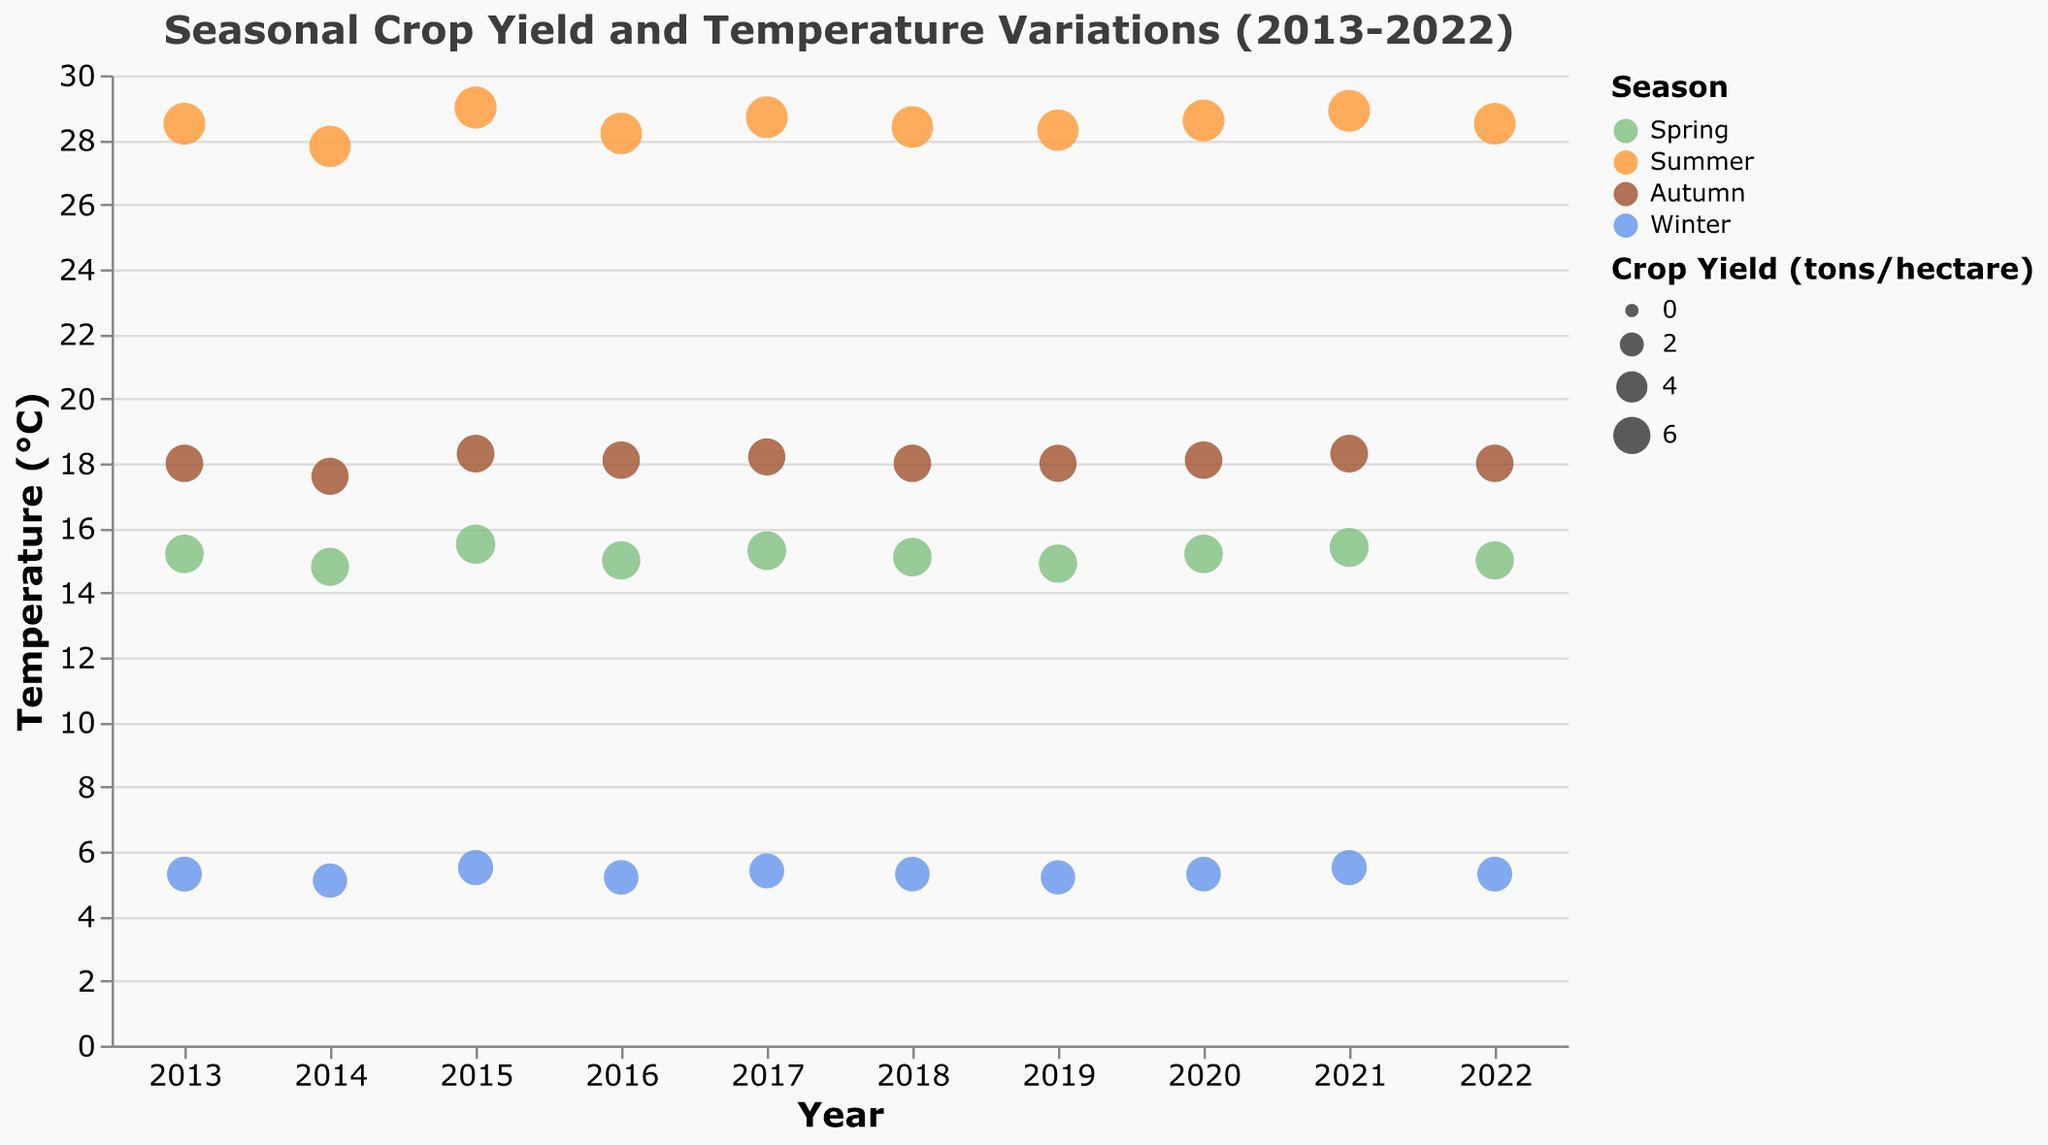1. What is the overall trend in temperatures from 2013 to 2022? Observe the y-axis labeled "Temperature (°C)" and the x-axis labeled "Year". Track the temperatures for each year and season, noting any overall increase or decrease.
Answer: The temperatures seem relatively stable over the years 2. Which season has the highest crop yield consistently across the years? Look at the "Crop Yield (tons/hectare)" represented by the size of the dots. Identify the season with the largest dots consistently from 2013 to 2022.
Answer: Summer 3. How does the crop yield in Spring of 2017 compare to the Spring of 2021? Refer to the "Crop Yield (tons/hectare)" for Spring in the years 2017 and 2021. Compare the sizes of the dots.
Answer: 6.6 (2017) vs 6.7 (2021) 4. What is the highest recorded temperature in the dataset? Check the y-axis labeled "Temperature (°C)" and identify the highest temperature value.
Answer: 29.0°C in Summer 2015 5. Compare the rainfall amounts in Winter across the years. Which year had the least rainfall? Look at the rainfall values during Winter across all years and identify the year with the lowest value on the y-axis labeled "Rainfall (mm)".
Answer: 2021 6. Is there a correlation between the amount of sunlight hours and crop yield in Summer seasons? Observe the Summer data points and compare the "Sunlight Hours" and "Crop Yield (tons/hectare)" by noting the sizes and horizontal positions.
Answer: Generally, more sunlight hours seem to correspond to higher crop yields 7. Which two seasons show the most significant difference in crop yield in 2020? Identify the size of the dots for each season in 2020. Calculate the differences in "Crop Yield (tons/hectare)" and find the largest one.
Answer: Spring and Summer (7.8 - 6.5 = 1.3 tons/hectare) 8. What year had the highest Sunlight Hours in Summer, and what was the crop yield that year? Look for the maximum "Sunlight Hours" during Summer seasons over the years and note the corresponding "Crop Yield (tons/hectare)".
Answer: 2021 with 2130 hours and 7.8 tons/hectare 9. During which season does the temperature have the smallest range across the years? Compare the temperature ranges of each season from 2013 to 2022 by identifying the maximum and minimum values and calculating the differences.
Answer: Winter 10. How much did the crop yield in Winter of 2013 differ from that of 2014? Subtract the "Crop Yield (tons/hectare)" in Winter 2014 from Winter 2013.
Answer: 5.2 - 5.0 = 0.2 tons/hectare 